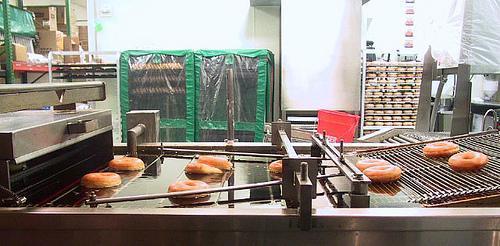How many donuts are there?
Give a very brief answer. 1. How many people are cutting the cake?
Give a very brief answer. 0. 